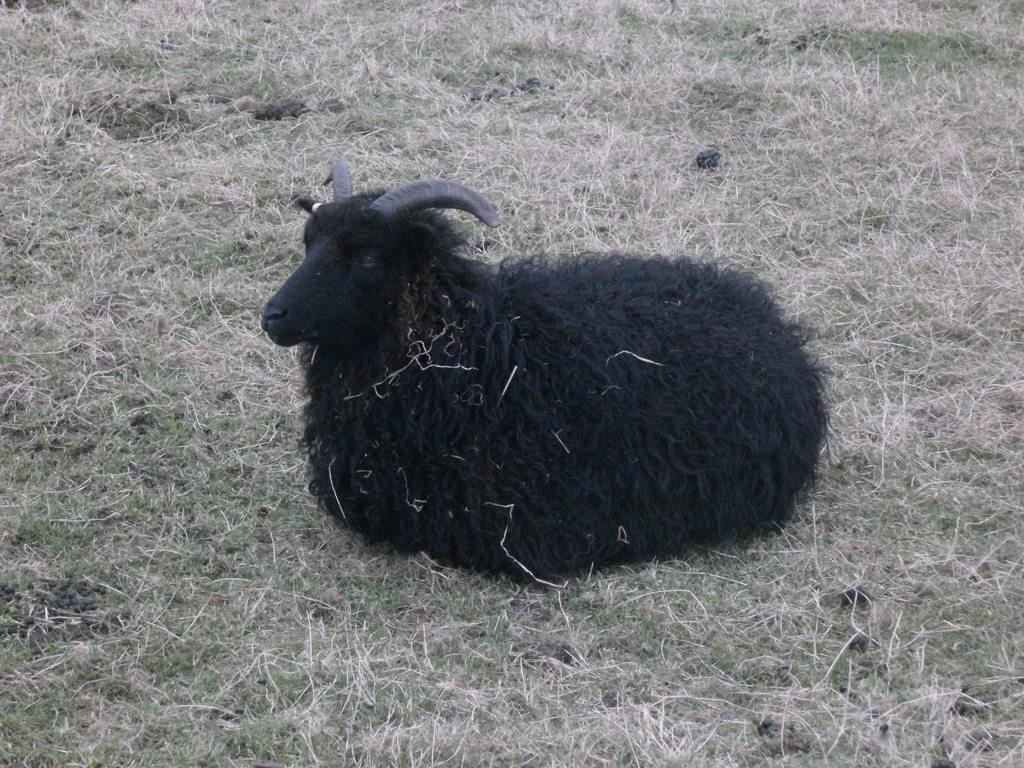How would you summarize this image in a sentence or two? In this picture we can see a black color sheep sitting, at the bottom there is grass. 